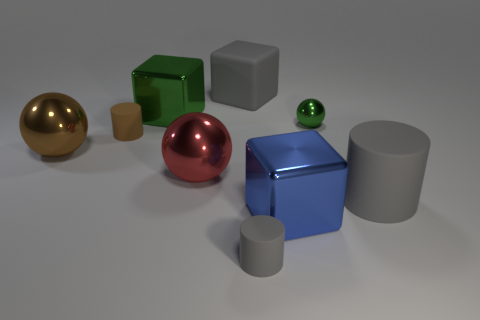Add 1 big purple matte objects. How many objects exist? 10 Subtract 1 red balls. How many objects are left? 8 Subtract all blocks. How many objects are left? 6 Subtract all gray matte blocks. Subtract all red metal balls. How many objects are left? 7 Add 7 big matte things. How many big matte things are left? 9 Add 7 gray matte cylinders. How many gray matte cylinders exist? 9 